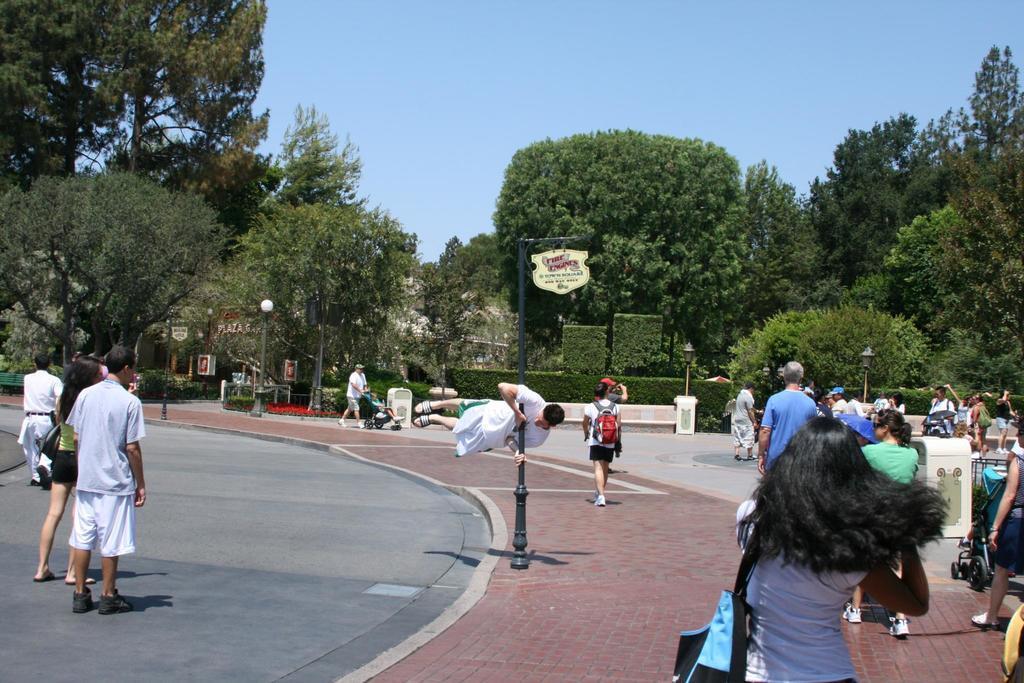Please provide a concise description of this image. On the left side few people are walking on the road, here many people are walking on the footpath. These are the green color trees, at the top it is the sky. 